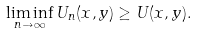Convert formula to latex. <formula><loc_0><loc_0><loc_500><loc_500>\liminf _ { n \to \infty } U _ { n } ( x , y ) \geq U ( x , y ) .</formula> 